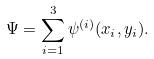Convert formula to latex. <formula><loc_0><loc_0><loc_500><loc_500>\Psi = \sum _ { i = 1 } ^ { 3 } \psi ^ { ( i ) } ( x _ { i } , y _ { i } ) .</formula> 